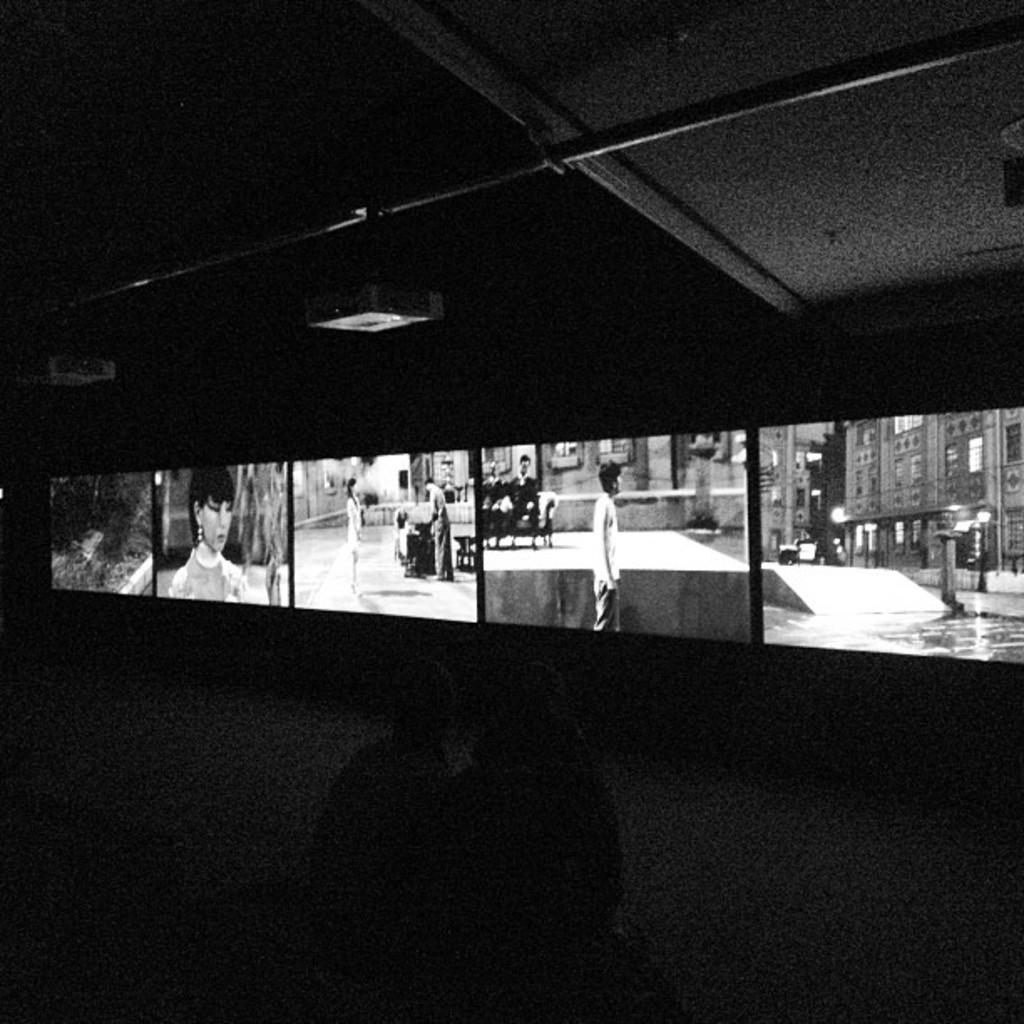What is the main subject of the image? There is a person standing in the image. What can be seen in the background of the image? There are buildings and light poles in the background of the image. What is visible in the sky in the image? The sky is visible in the background of the image. How is the image presented in terms of color? The image is in black and white. What type of egg is being carried in the person's pocket in the image? There is no egg or pocket visible in the image; the person is not carrying anything. Can you see a bear in the image? There is no bear present in the image. 